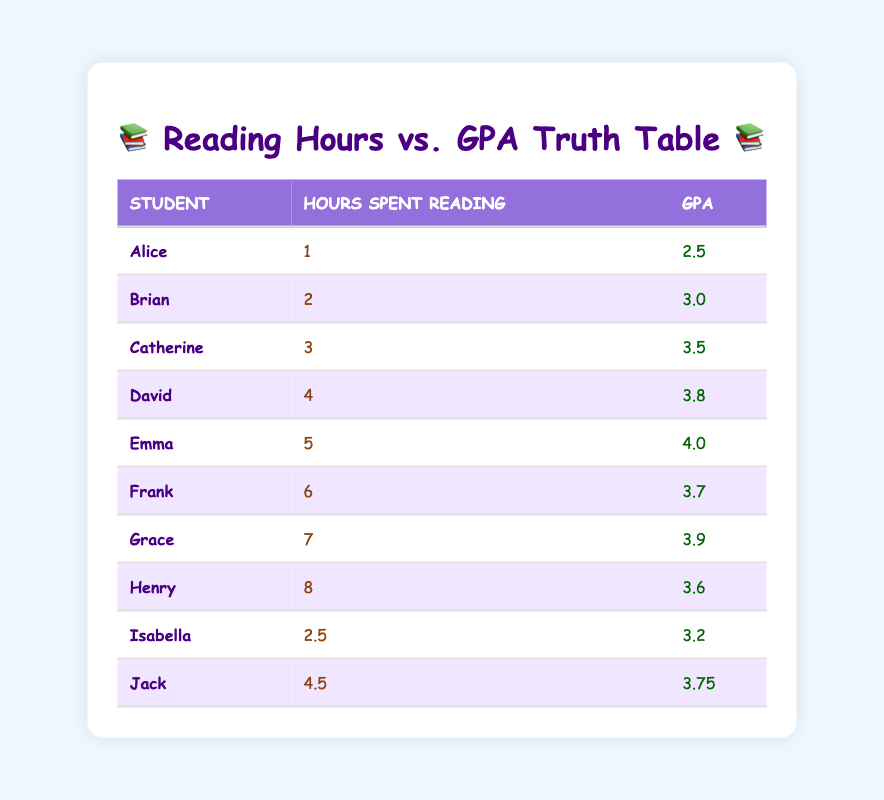What is the GPA of Emma? By looking at the table, we can find Emma listed under the student column. The corresponding GPA value is directly next to her name.
Answer: 4.0 How many hours did Jack spend reading? Jack's entry in the table shows that he spent 4.5 hours reading, which is clearly displayed in the hours spent reading column.
Answer: 4.5 What is the highest GPA in the table? To determine the highest GPA, we can look through the GPA column and identify the maximum value. The highest GPA recorded in the table is 4.0 earned by Emma.
Answer: 4.0 Is there a student with a GPA of 3.6 or higher? By scanning the GPA column, we find multiple students with GPAs at or above 3.6: David, Emma, Frank, Grace, and Henry. This confirms that there are students who meet the criterion.
Answer: Yes What is the average GPA of students who spent more than 5 hours reading? We look for students who read for more than 5 hours: Frank (3.7), Grace (3.9), and Henry (3.6). Summing their GPAs gives: 3.7 + 3.9 + 3.6 = 11.2. Dividing by the number of students (3), we get an average GPA of 11.2 / 3 = 3.73.
Answer: 3.73 What is the difference in GPA between the student who read the most hours and the one who read the least? We identify the student who read the most hours, which is Henry with a GPA of 3.6, and the student who read the least, Alice with a GPA of 2.5. Calculating the difference: 3.6 - 2.5 = 1.1.
Answer: 1.1 How many students read for 3 hours or less? Referring to the hours spent reading column, the students who fit this criterion are Alice (1), Brian (2), and Isabella (2.5), giving us a total of three students.
Answer: 3 Which student had the lowest GPA? By examining the GPA column, we can find Alice has the lowest GPA of 2.5.
Answer: Alice Is there a correlation between hours spent reading and GPA? Given that as hours spent reading increase, GPA also tends to increase, we can infer a positive correlation.
Answer: Yes 